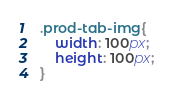Convert code to text. <code><loc_0><loc_0><loc_500><loc_500><_CSS_>.prod-tab-img{
    width: 100px;
    height: 100px;
}</code> 